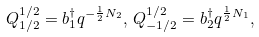Convert formula to latex. <formula><loc_0><loc_0><loc_500><loc_500>Q ^ { 1 / 2 } _ { 1 / 2 } = b _ { 1 } ^ { \dagger } q ^ { - \frac { 1 } { 2 } N _ { 2 } } , \, Q ^ { 1 / 2 } _ { - 1 / 2 } = b _ { 2 } ^ { \dagger } q ^ { \frac { 1 } { 2 } N _ { 1 } } ,</formula> 